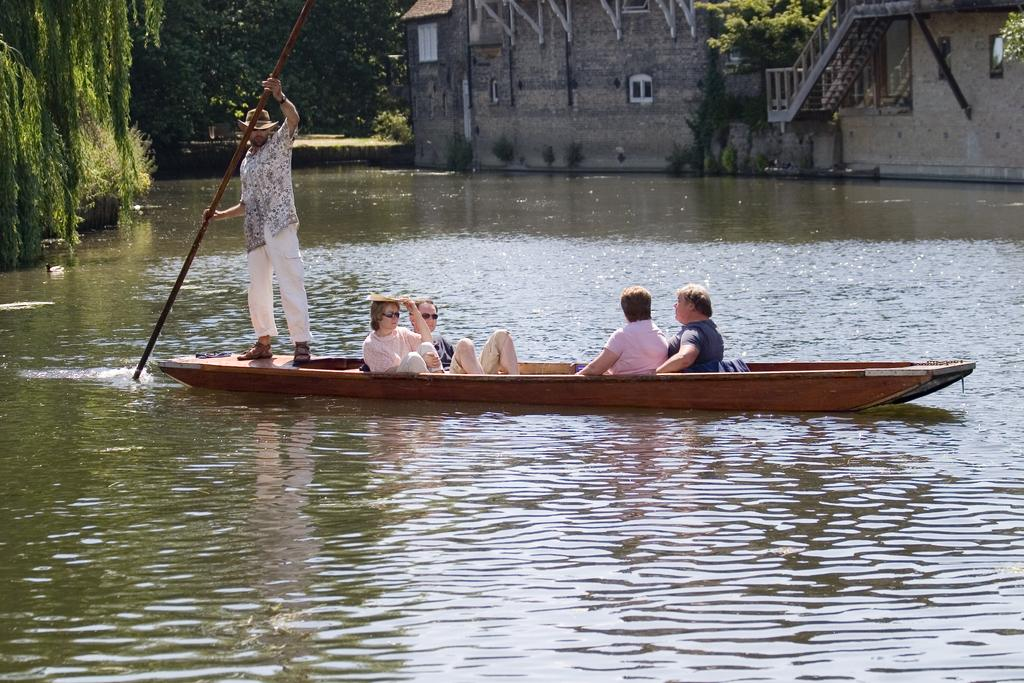What are the people in the image doing? The people in the image are seated in a boat. What is the man standing in the boat doing? The man is holding a stick in his hand. What can be seen in the background of the image? There is a building and trees visible in the image. Can you describe the appearance of one of the people in the boat? There is a man wearing a cap in the image. What flavor of ice cream is on the shelf in the image? There is no ice cream or shelf present in the image. How does the group of people in the boat interact with each other? The image does not show any interactions between the people in the boat, only their individual activities. 